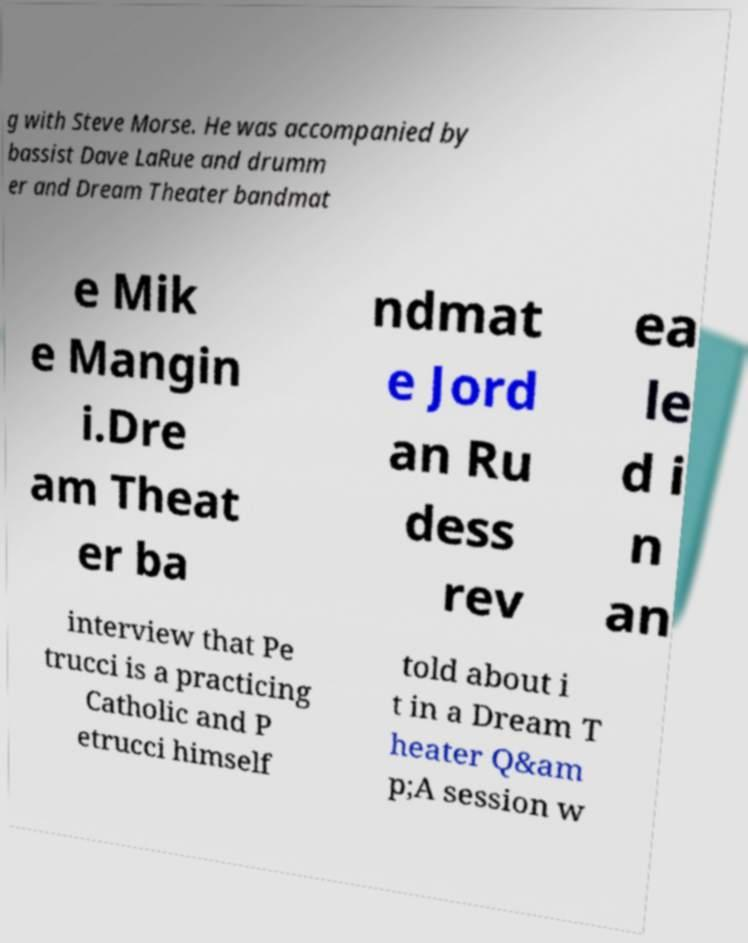For documentation purposes, I need the text within this image transcribed. Could you provide that? g with Steve Morse. He was accompanied by bassist Dave LaRue and drumm er and Dream Theater bandmat e Mik e Mangin i.Dre am Theat er ba ndmat e Jord an Ru dess rev ea le d i n an interview that Pe trucci is a practicing Catholic and P etrucci himself told about i t in a Dream T heater Q&am p;A session w 